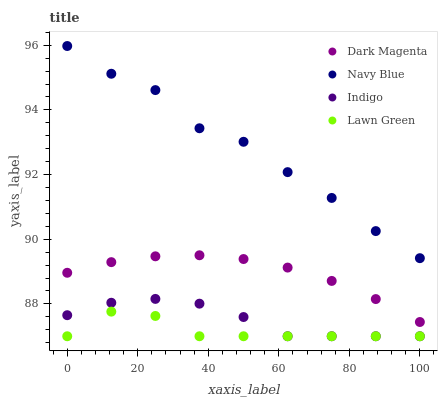Does Lawn Green have the minimum area under the curve?
Answer yes or no. Yes. Does Navy Blue have the maximum area under the curve?
Answer yes or no. Yes. Does Indigo have the minimum area under the curve?
Answer yes or no. No. Does Indigo have the maximum area under the curve?
Answer yes or no. No. Is Dark Magenta the smoothest?
Answer yes or no. Yes. Is Navy Blue the roughest?
Answer yes or no. Yes. Is Indigo the smoothest?
Answer yes or no. No. Is Indigo the roughest?
Answer yes or no. No. Does Indigo have the lowest value?
Answer yes or no. Yes. Does Dark Magenta have the lowest value?
Answer yes or no. No. Does Navy Blue have the highest value?
Answer yes or no. Yes. Does Indigo have the highest value?
Answer yes or no. No. Is Lawn Green less than Dark Magenta?
Answer yes or no. Yes. Is Navy Blue greater than Lawn Green?
Answer yes or no. Yes. Does Indigo intersect Lawn Green?
Answer yes or no. Yes. Is Indigo less than Lawn Green?
Answer yes or no. No. Is Indigo greater than Lawn Green?
Answer yes or no. No. Does Lawn Green intersect Dark Magenta?
Answer yes or no. No. 